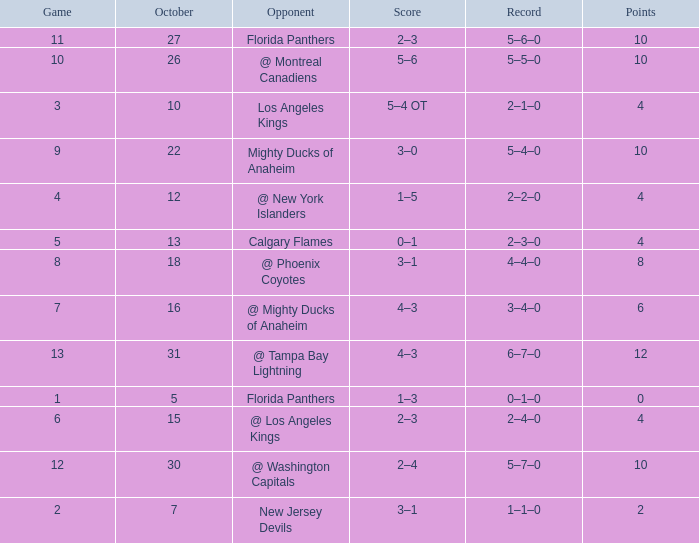What team has a score of 11 5–6–0. 